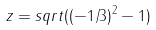<formula> <loc_0><loc_0><loc_500><loc_500>z = s q r t ( ( - 1 / 3 ) ^ { 2 } - 1 )</formula> 